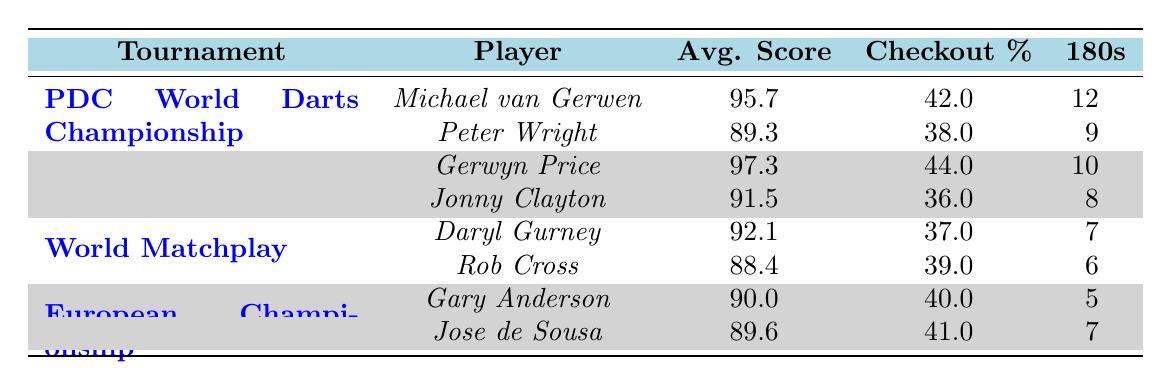What is the highest average score among the players listed? The average scores of the players are 95.7 (Michael van Gerwen), 89.3 (Peter Wright), 97.3 (Gerwyn Price), 91.5 (Jonny Clayton), 92.1 (Daryl Gurney), 88.4 (Rob Cross), 90.0 (Gary Anderson), and 89.6 (Jose de Sousa). The highest score is 97.3 by Gerwyn Price.
Answer: 97.3 Which player had the highest checkout percentage? The checkout percentages are as follows: 42 (Michael van Gerwen), 38 (Peter Wright), 44 (Gerwyn Price), 36 (Jonny Clayton), 37 (Daryl Gurney), 39 (Rob Cross), 40 (Gary Anderson), and 41 (Jose de Sousa). The highest percentage is 44 by Gerwyn Price.
Answer: 44 How many maximum 180s did Michael van Gerwen hit? The maximum 180s for Michael van Gerwen is listed as 12 in the table.
Answer: 12 What is the average score of all the players combined? To find the average score, sum the average scores: 95.7 + 89.3 + 97.3 + 91.5 + 92.1 + 88.4 + 90.0 + 89.6 = 834.0. There are 8 players, so the average is 834.0 / 8 = 104.25.
Answer: 104.25 Did any player score more than 10 maximum 180s? Michael van Gerwen scored 12 maximum 180s, which is more than 10.
Answer: Yes Which tournament had the player with the lowest average score? The players' average scores in the tournaments are 95.7, 89.3, 97.3, 91.5, 92.1, 88.4, 90.0, and 89.6. The lowest average score is 88.4, which belongs to Rob Cross in the World Matchplay tournament.
Answer: World Matchplay What is the difference in checkout percentage between the highest and the lowest player? The highest checkout percentage is 44 (Gerwyn Price) and the lowest is 36 (Jonny Clayton), so the difference is 44 - 36 = 8.
Answer: 8 Which player had the lowest number of maximum 180s? The maximum 180s are 12 (Michael van Gerwen), 9 (Peter Wright), 10 (Gerwyn Price), 8 (Jonny Clayton), 7 (Daryl Gurney), 6 (Rob Cross), 5 (Gary Anderson), and 7 (Jose de Sousa). The lowest number is 5 by Gary Anderson.
Answer: Gary Anderson How does Peter Wright's average score compare to Daryl Gurney's? Peter Wright's average score is 89.3 and Daryl Gurney's is 92.1. Comparing the two, Daryl Gurney has a higher average score by 2.8 points (92.1 - 89.3 = 2.8).
Answer: Daryl Gurney has a higher score by 2.8 points How many players scored an average of over 90? The players with average scores over 90 are: Michael van Gerwen (95.7), Gerwyn Price (97.3), Daryl Gurney (92.1), and Gary Anderson (90.0). This means there are 4 players who scored over 90.
Answer: 4 